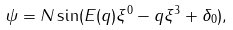<formula> <loc_0><loc_0><loc_500><loc_500>\psi = N \sin ( E ( q ) \xi ^ { 0 } - q \xi ^ { 3 } + \delta _ { 0 } ) ,</formula> 